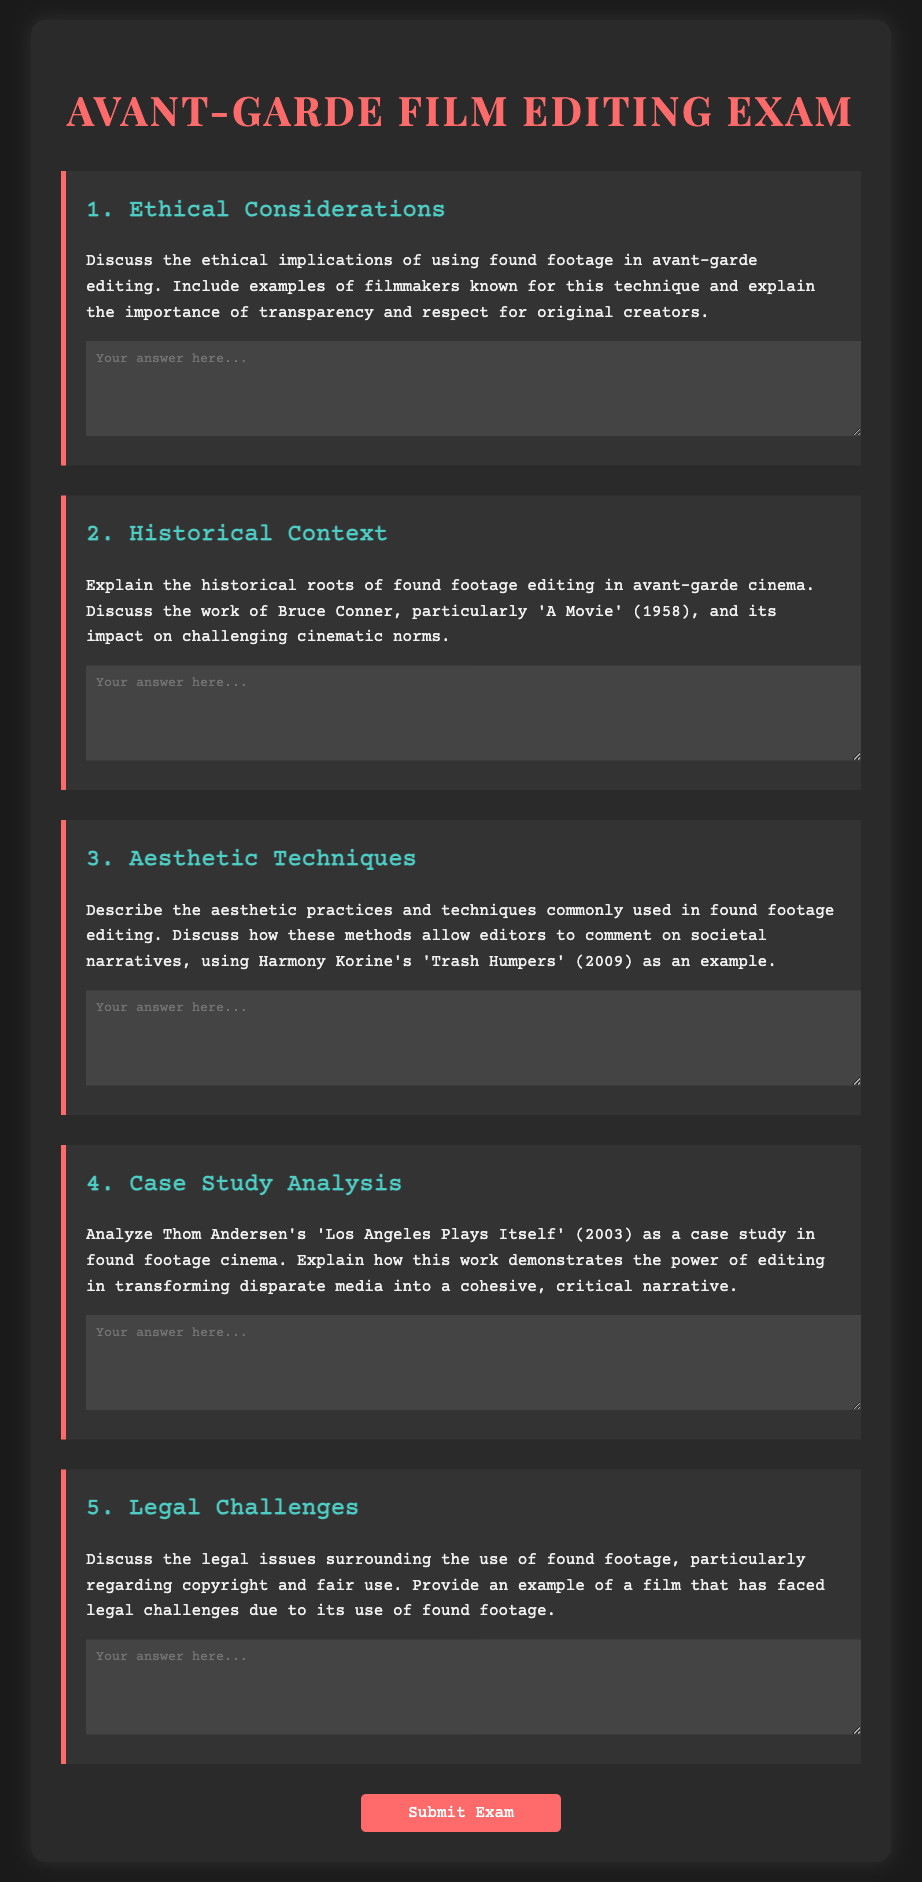What is the title of the exam? The title of the exam is displayed prominently at the top of the document.
Answer: Avant-Garde Film Editing Exam How many main questions are included in the exam? The exam contains a total of five main questions as listed in the document.
Answer: 5 Who is the filmmaker associated with 'A Movie'? The document references Bruce Conner as the filmmaker known for 'A Movie'.
Answer: Bruce Conner What year was 'A Movie' released? The document provides the year of release for 'A Movie' as part of the historical context question.
Answer: 1958 Which film is mentioned as an example of aesthetic practices in found footage editing? The document presents 'Trash Humpers' as an example of aesthetic practices related to found footage editing.
Answer: Trash Humpers What type of issues does the last question of the exam address? The final question specifically discusses legal challenges related to the use of found footage.
Answer: Legal challenges What color is used for the title text? The title text color specified in the CSS style for the document can be identified.
Answer: #ff6b6b What is the background color of the container? The background color of the container in the document is defined in the CSS styling section.
Answer: #2a2a2a 